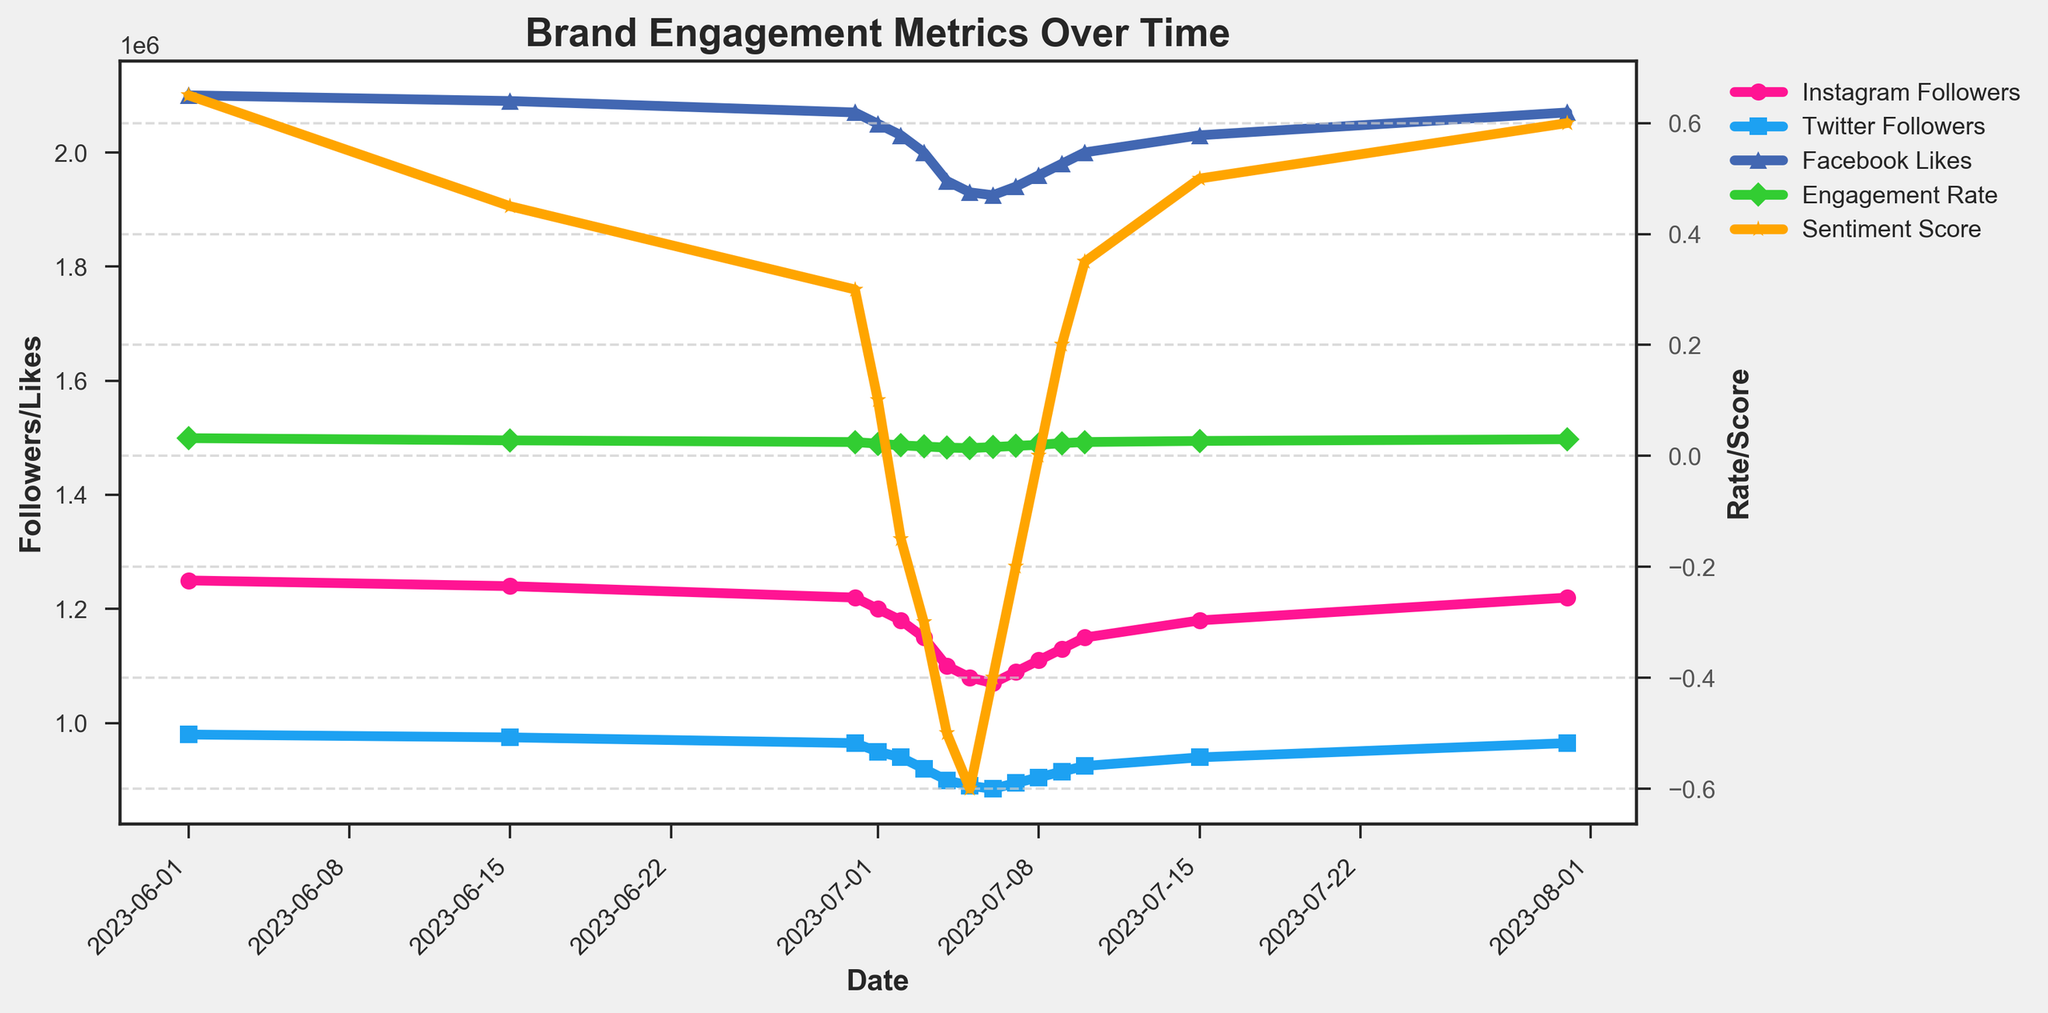Which social media platform had the lowest number of followers on July 4, 2023? On July 4, 2023, Instagram had 1,100,000 followers, Twitter had 900,000 followers, and Facebook had 1,950,000 likes. Twitter had the lowest number of followers.
Answer: Twitter What was the difference in Engagement Rate between July 1, 2023, and July 10, 2023? The Engagement Rate on July 1, 2023 was 2.2%, and on July 10, 2023, it was 2.5%. The difference is 2.5% - 2.2% = 0.3%.
Answer: 0.3% How did the Sentiment Score change between July 2, 2023, and July 9, 2023? On July 2, 2023, the Sentiment Score was -0.15, and on July 9, 2023, it was 0.20. The change is 0.20 - (-0.15) = 0.35.
Answer: 0.35 Which date showed the highest Engagement Rate? The highest Engagement Rate is seen on July 31, 2023, at a rate of 3.0%.
Answer: July 31, 2023 By how much did the Instagram followers increase from July 4, 2023, to July 8, 2023? On July 4, 2023, Instagram followers were 1,100,000, and on July 8, 2023, they were 1,110,000. The increase is 1,110,000 - 1,100,000 = 10,000 followers.
Answer: 10,000 Compare the trend of Twitter followers and Sentiment Score from July 5, 2023, to July 9, 2023. From July 5 to July 9, Twitter followers increased from 890,000 to 915,000, while the Sentiment Score increased from -0.60 to 0.20. Both metrics showed upward trends, with Twitter followers rising by 25,000 and Sentiment Score rising by 0.80.
Answer: Upward trend in both What was the Engagement Rate trend from July 2, 2023, to July 7, 2023? The Engagement Rate on July 2, 2023 was 1.9%, and it increased each day, reaching 1.8% on July 7, 2023. Thus, the trend is an increase.
Answer: Increasing Which had a greater increase from July 6, 2023, to July 10, 2023: Facebook likes or the Sentiment Score? Facebook likes increased from 1,925,000 to 2,000,000, which is an increase of 75,000. The Sentiment Score increased from -0.40 to 0.35, which is an increase of 0.75. Comparing these, the Sentiment Score had the larger increase of 0.75.
Answer: Sentiment Score What was the Sentiment Score when the Instagram followers reached 1,150,000? The Instagram followers reached 1,150,000 on July 10, 2023 and the corresponding Sentiment Score was 0.35.
Answer: 0.35 